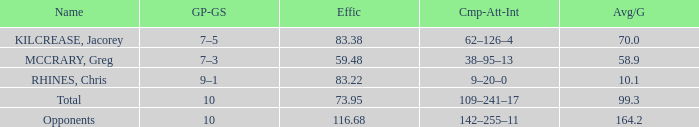What is the avg/g of Rhines, Chris, who has an effic greater than 73.95? 10.1. 